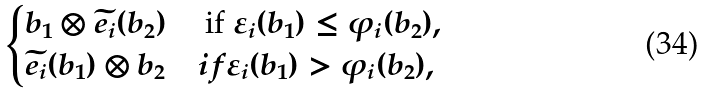<formula> <loc_0><loc_0><loc_500><loc_500>\begin{cases} b _ { 1 } \otimes \widetilde { e _ { i } } ( b _ { 2 } ) & \text { if } \varepsilon _ { i } ( b _ { 1 } ) \leq \varphi _ { i } ( b _ { 2 } ) , \\ \widetilde { e _ { i } } ( b _ { 1 } ) \otimes b _ { 2 } & i f \varepsilon _ { i } ( b _ { 1 } ) > \varphi _ { i } ( b _ { 2 } ) , \end{cases}</formula> 